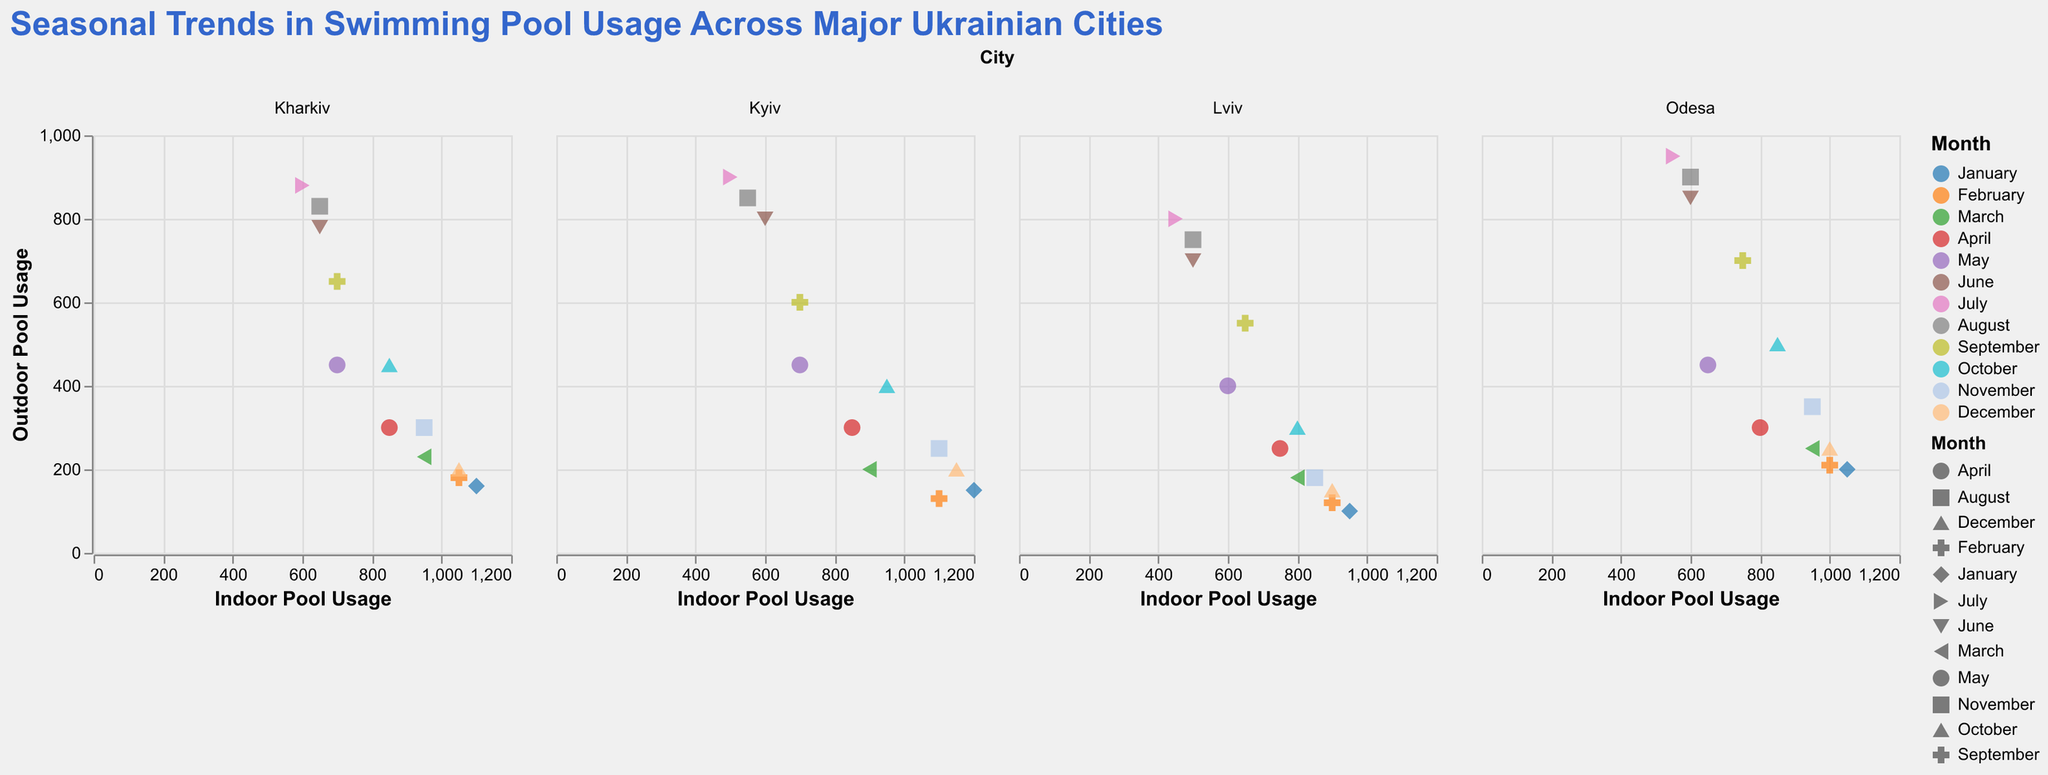How does Indoor Pool Usage compare across different months for Kyiv? To answer this, we need to look at the indoor pool usage data points for Kyiv in each month. The trend shows a high indoor pool usage in winter months and a notable decrease during the summer. Specifically, January and February show high values around 1200 and 1100, respectively, while July and August have much lower usage around 500-550.
Answer: Higher in winter, lower in summer Which city shows the highest outdoor pool usage in August? To find this, we'll look at the outdoor pool usage data points for August across all cities. Odesa shows the highest outdoor pool usage for August with a value of 900.
Answer: Odesa What is the difference in indoor pool usage between January and July in Lviv? We locate the data points for indoor pool usage in January and July for Lviv. January has 950 while July has 450. The difference is 950 - 450 = 500.
Answer: 500 Which city has the highest indoor pool usage overall? First, we locate the data points for indoor pool usage for all cities. Kyiv has the highest individual point with 1200 in January.
Answer: Kyiv What is the median outdoor pool usage in April for all cities? We collect the outdoor pool usage data for April for all cities: Kyiv (300), Lviv (250), Odesa (300), and Kharkiv (300). The dataset is already sorted: 250, 300, 300, 300. Since there is an even number, the median value is the average of the two middle values: (300 + 300) / 2 = 300.
Answer: 300 